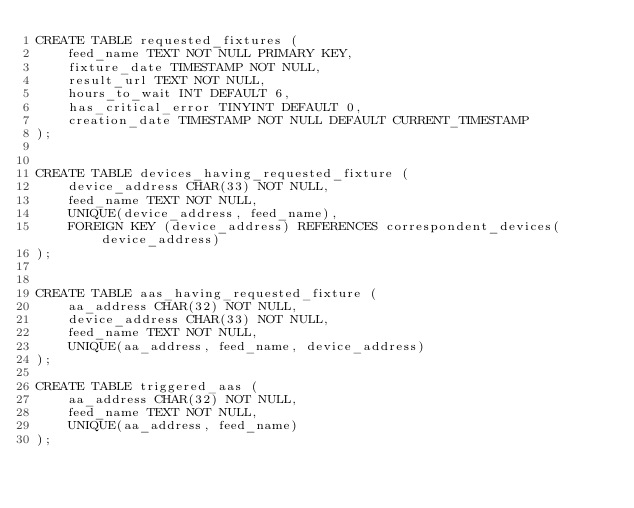Convert code to text. <code><loc_0><loc_0><loc_500><loc_500><_SQL_>CREATE TABLE requested_fixtures (
	feed_name TEXT NOT NULL PRIMARY KEY,
	fixture_date TIMESTAMP NOT NULL,
	result_url TEXT NOT NULL,
	hours_to_wait INT DEFAULT 6,
	has_critical_error TINYINT DEFAULT 0,
	creation_date TIMESTAMP NOT NULL DEFAULT CURRENT_TIMESTAMP
);


CREATE TABLE devices_having_requested_fixture (
	device_address CHAR(33) NOT NULL,
	feed_name TEXT NOT NULL,
	UNIQUE(device_address, feed_name),
	FOREIGN KEY (device_address) REFERENCES correspondent_devices(device_address)
);


CREATE TABLE aas_having_requested_fixture (
	aa_address CHAR(32) NOT NULL,
	device_address CHAR(33) NOT NULL,
	feed_name TEXT NOT NULL,
	UNIQUE(aa_address, feed_name, device_address)
);

CREATE TABLE triggered_aas (
	aa_address CHAR(32) NOT NULL,
	feed_name TEXT NOT NULL,
	UNIQUE(aa_address, feed_name)
);

</code> 